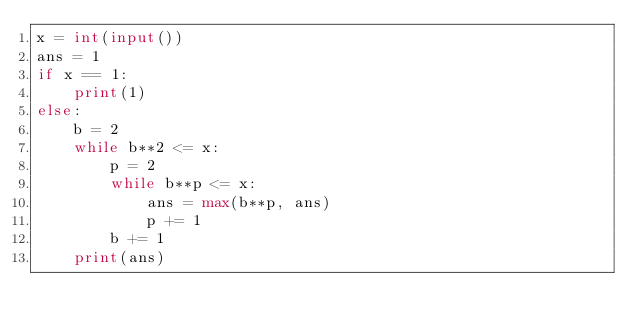<code> <loc_0><loc_0><loc_500><loc_500><_Python_>x = int(input())
ans = 1
if x == 1:
    print(1)
else:
    b = 2
    while b**2 <= x:
        p = 2
        while b**p <= x:
            ans = max(b**p, ans)
            p += 1
        b += 1
    print(ans)</code> 